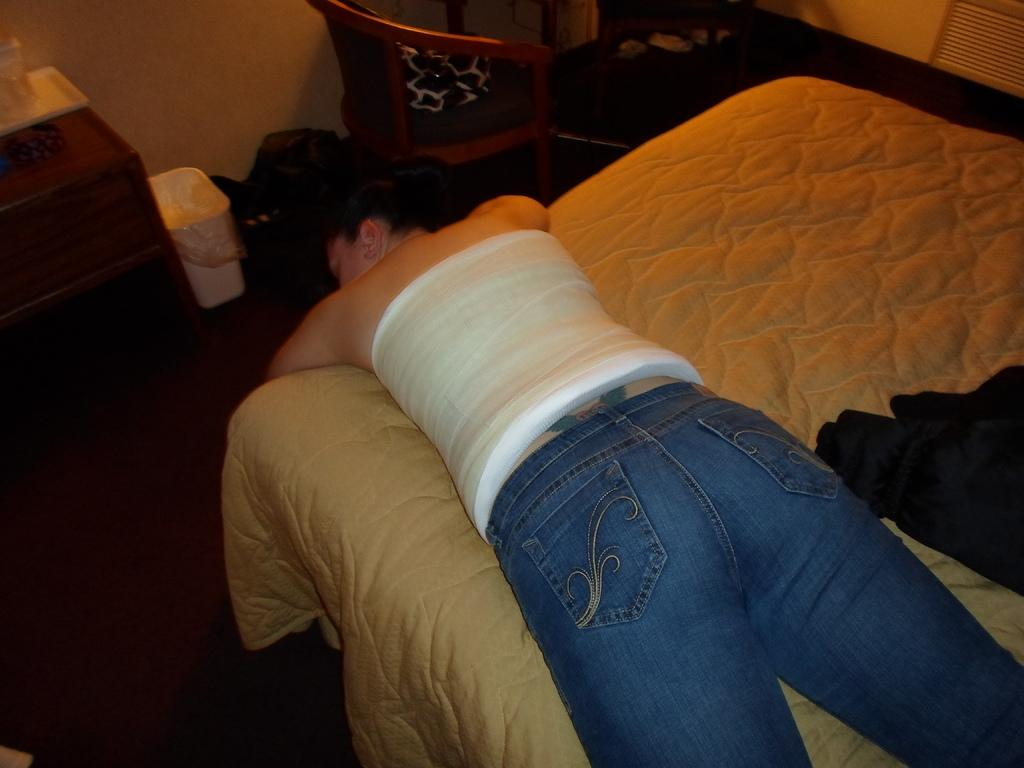What is the woman doing in the image? The woman is laying on a bed. What objects are on the table in the image? There is a tray and a glass on the table in the image. Can you describe any furniture in the image besides the bed? Yes, there is a chair in the image. What type of honey is being poured from the gun in the image? There is no honey or gun present in the image. 